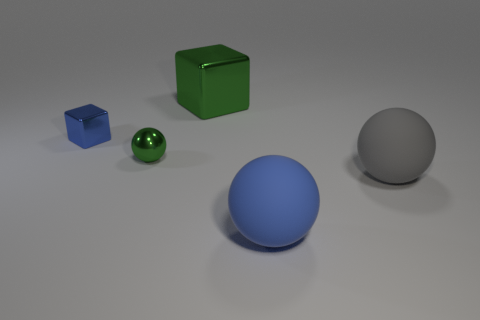The metallic object that is the same color as the tiny ball is what shape?
Offer a very short reply. Cube. The metal thing that is the same size as the blue cube is what color?
Give a very brief answer. Green. There is a big metallic cube; is its color the same as the sphere behind the big gray rubber object?
Keep it short and to the point. Yes. There is a blue object that is right of the block that is behind the blue cube; what is its material?
Offer a very short reply. Rubber. How many cubes are both in front of the large shiny cube and on the right side of the blue metal thing?
Offer a very short reply. 0. How many other things are the same size as the gray matte sphere?
Your answer should be compact. 2. Is the shape of the green metallic object that is in front of the large green block the same as the blue object that is to the right of the large metal thing?
Provide a short and direct response. Yes. There is a small block; are there any metallic blocks on the right side of it?
Give a very brief answer. Yes. There is another metal thing that is the same shape as the small blue shiny object; what is its color?
Ensure brevity in your answer.  Green. There is a big object behind the small metallic sphere; what material is it?
Provide a short and direct response. Metal. 